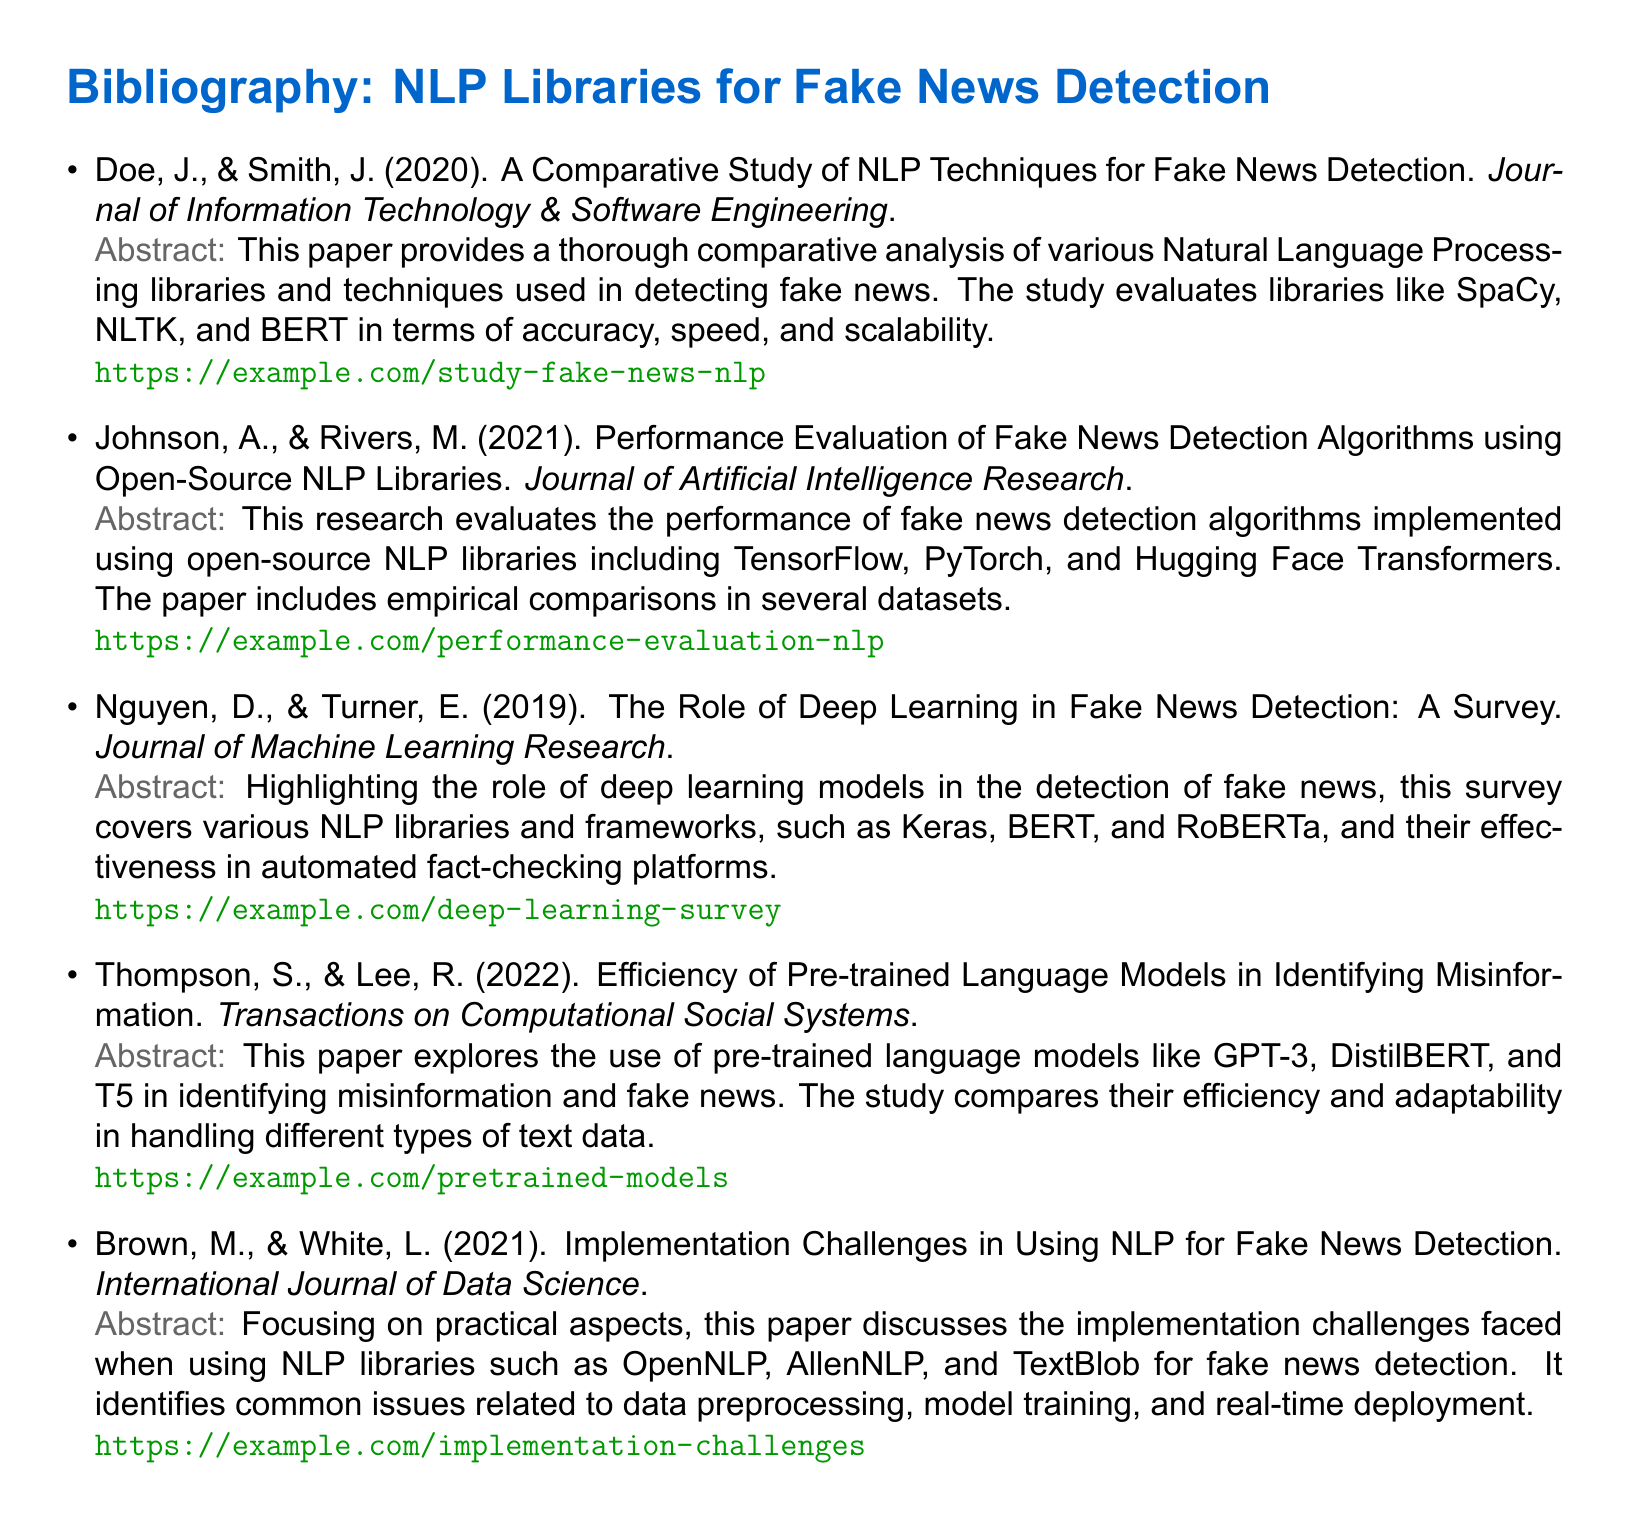What is the title of the first referenced paper? The title of the first paper in the bibliography is provided clearly after the author names, which is "A Comparative Study of NLP Techniques for Fake News Detection."
Answer: A Comparative Study of NLP Techniques for Fake News Detection Who are the authors of the paper published in 2021 about performance evaluation? The authors' names are listed directly after the title and publication year in the bibliography, which are Johnson, A., and Rivers, M.
Answer: Johnson, A., & Rivers, M In what year was the paper that surveyed deep learning's role in fake news detection published? The year is mentioned right after the author's names in the document, which is 2019.
Answer: 2019 Which NLP libraries are evaluated in Thompson and Lee's 2022 paper? The evaluated libraries are listed clearly in the abstract of the paper, which include GPT-3, DistilBERT, and T5.
Answer: GPT-3, DistilBERT, and T5 Which journal published the paper discussing implementation challenges in NLP for fake news detection? The journal name can be found within the citation of the bibliography entry, which is the International Journal of Data Science.
Answer: International Journal of Data Science What is the main focus of Brown and White's 2021 paper? The main focus is clearly indicated in the abstract, which discusses implementation challenges faced when using NLP libraries for fake news detection.
Answer: Implementation challenges How many papers are listed in the bibliography? The number can be easily counted based on the list provided and amounts to five distinct entries in the bibliography.
Answer: Five What type of models does Nguyen and Turner's paper focus on? The type of models is provided in the title and abstract of their paper, which discusses deep learning models.
Answer: Deep learning models Which paper compares various NLP libraries in terms of accuracy, speed, and scalability? This information can be inferred directly from the abstract of the first reference, which covers a comparative analysis of NLP libraries.
Answer: A Comparative Study of NLP Techniques for Fake News Detection 